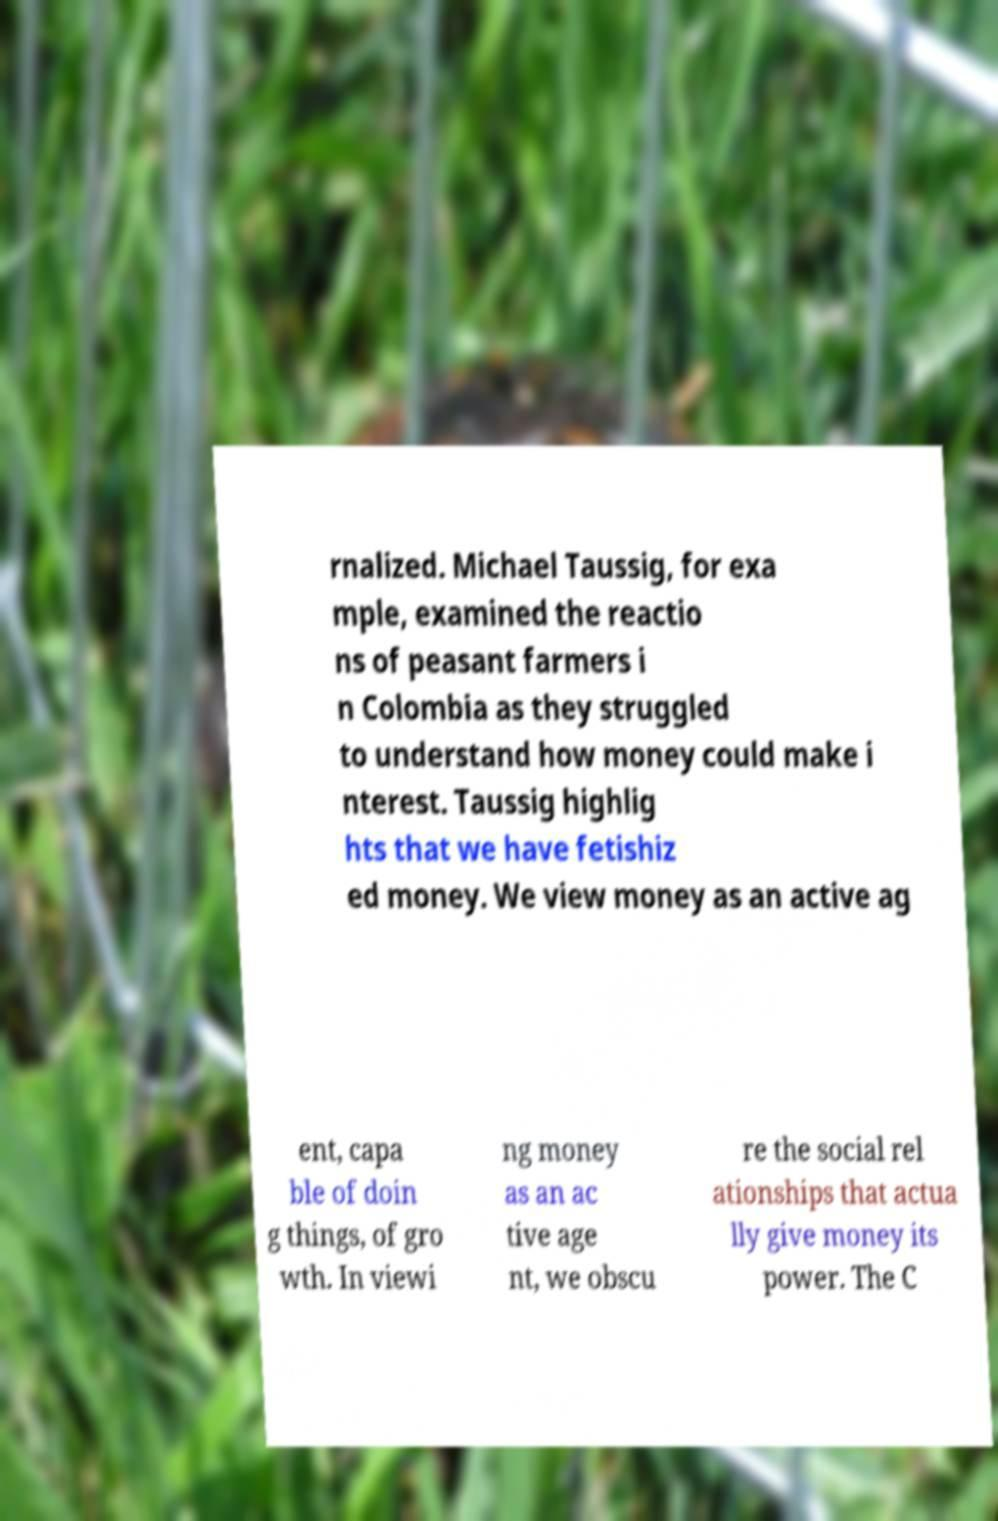There's text embedded in this image that I need extracted. Can you transcribe it verbatim? rnalized. Michael Taussig, for exa mple, examined the reactio ns of peasant farmers i n Colombia as they struggled to understand how money could make i nterest. Taussig highlig hts that we have fetishiz ed money. We view money as an active ag ent, capa ble of doin g things, of gro wth. In viewi ng money as an ac tive age nt, we obscu re the social rel ationships that actua lly give money its power. The C 